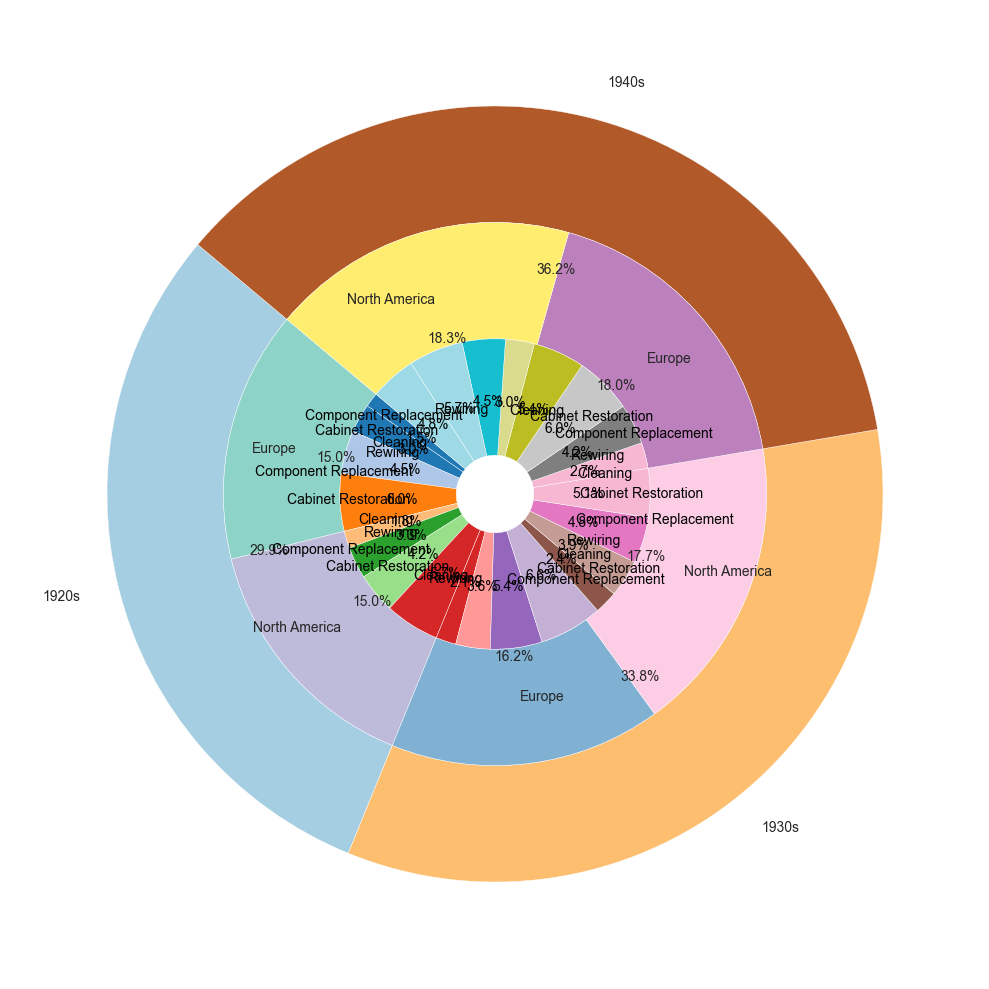Which era has the highest overall percentage for restoration techniques? By looking at the outermost layer of the nested pie chart, we can identify the era with the largest segment. Calculate the sum of percentages for each era and identify the maximum.
Answer: 1940s Which region in the 1930s shows the largest percentage for the rewiring technique? Observe the segments related to the rewiring technique in the middle ring of the pie chart for the 1930s, and identify the region with the larger segment.
Answer: Europe Comparing cabinet restoration in the 1920s and 1940s, which era had a higher percentage, and by how much? Find the segments representing cabinet restoration in both the 1920s and 1940s in the center ring, then subtract the smaller percentage from the larger one to find the difference.
Answer: 1940s, by 2% What percentage of cleaning techniques were used in Europe during the 1940s compared to North America in the same era? Check the segments for cleaning in the 1940s in both regions and compare their sizes to determine the percentage of each.
Answer: 10% vs. 9% In which era and region was component replacement the most utilized restoration technique, and what percentage did it account for? Look at the component replacement segment across all eras and regions in the innermost ring. Identify the largest segment and note the corresponding era and region along with its percentage.
Answer: 1940s, North America, 20% What was the total percentage of all restoration techniques used in North America across all eras? Sum up the percentages of all restoration techniques within the North America region from all the eras.
Answer: 188% What's the sum of percentages for cabinet restoration across all regions and eras? Calculate the sum of the cabinet restoration percentages for both North America and Europe in the 1920s, 1930s, and 1940s and sum them up.
Answer: 112% What is the trend of cleaning techniques from the 1920s to the 1940s in North America? Analyze the segments representing cleaning techniques in North America for the 1920s, 1930s, and 1940s. Observe whether the percentage is increasing or decreasing over the years.
Answer: Increasing Which restoration technique in Europe during the 1930s had the smallest percentage, and what was it? Identify the technique with the smallest segment in Europe during the 1930s in the innermost ring and note its percentage.
Answer: Cleaning, 8% How much more was the component replacement technique used in North America during the 1930s compared to Europe in the same era? Compare the segments for component replacement in North America and Europe for the 1930s, and calculate the difference in their percentages.
Answer: 2% 